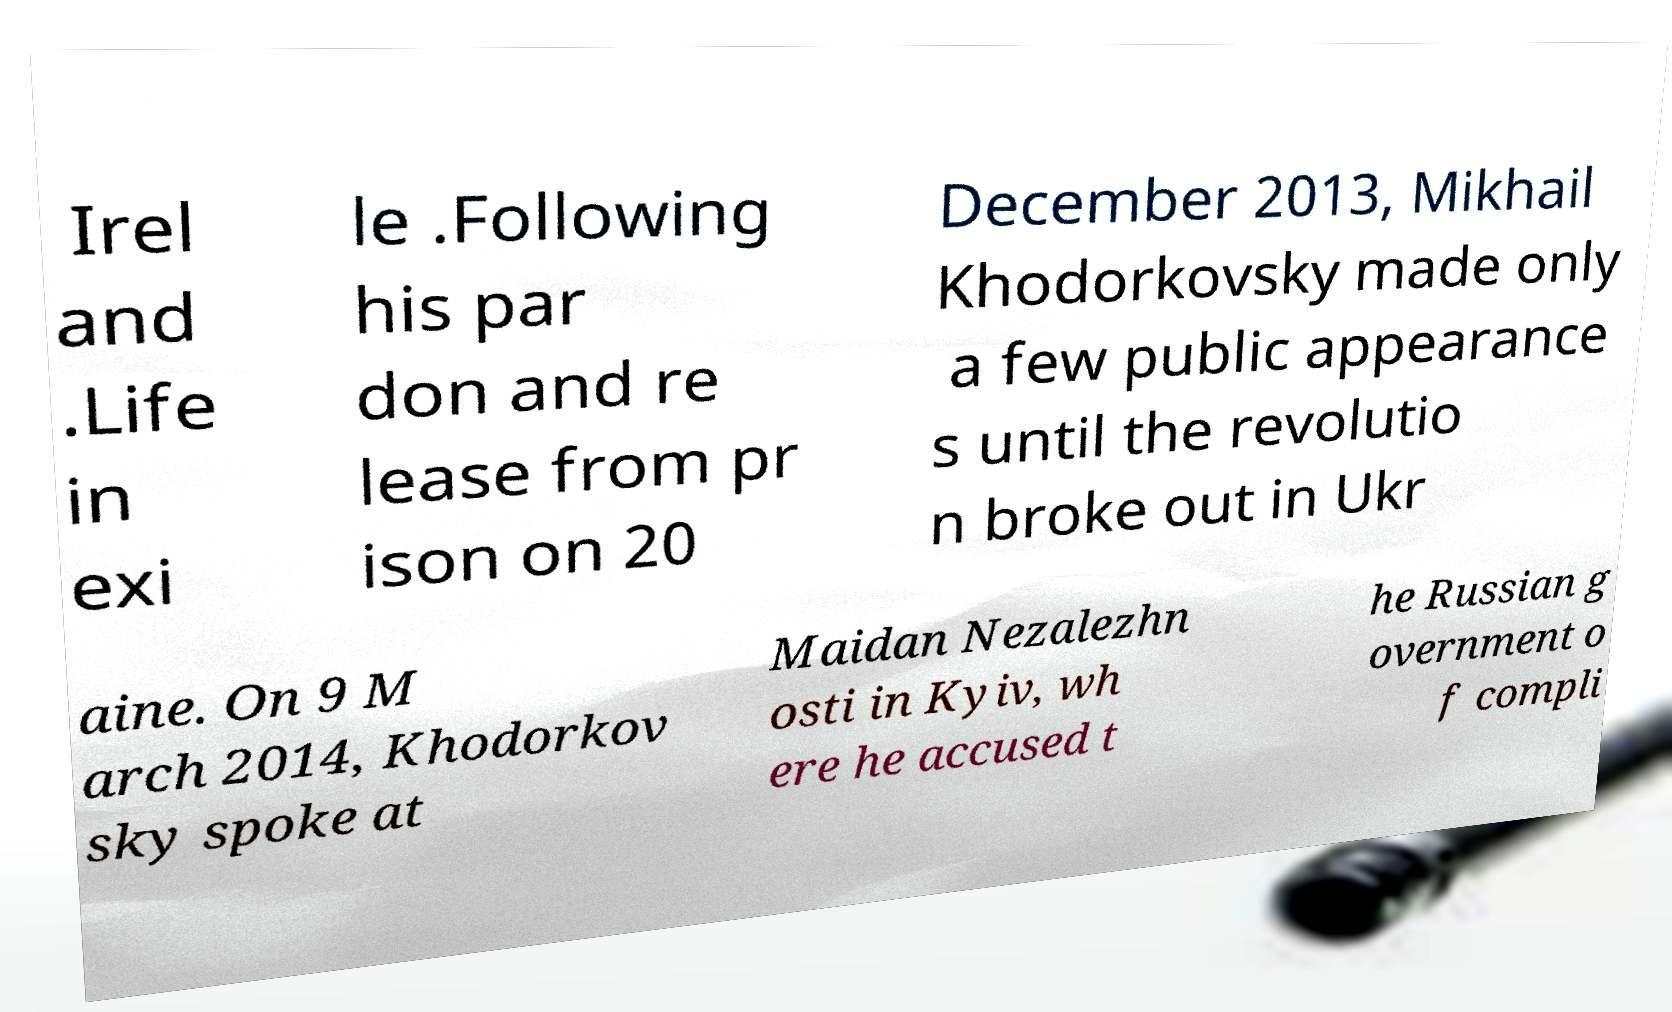Could you assist in decoding the text presented in this image and type it out clearly? Irel and .Life in exi le .Following his par don and re lease from pr ison on 20 December 2013, Mikhail Khodorkovsky made only a few public appearance s until the revolutio n broke out in Ukr aine. On 9 M arch 2014, Khodorkov sky spoke at Maidan Nezalezhn osti in Kyiv, wh ere he accused t he Russian g overnment o f compli 